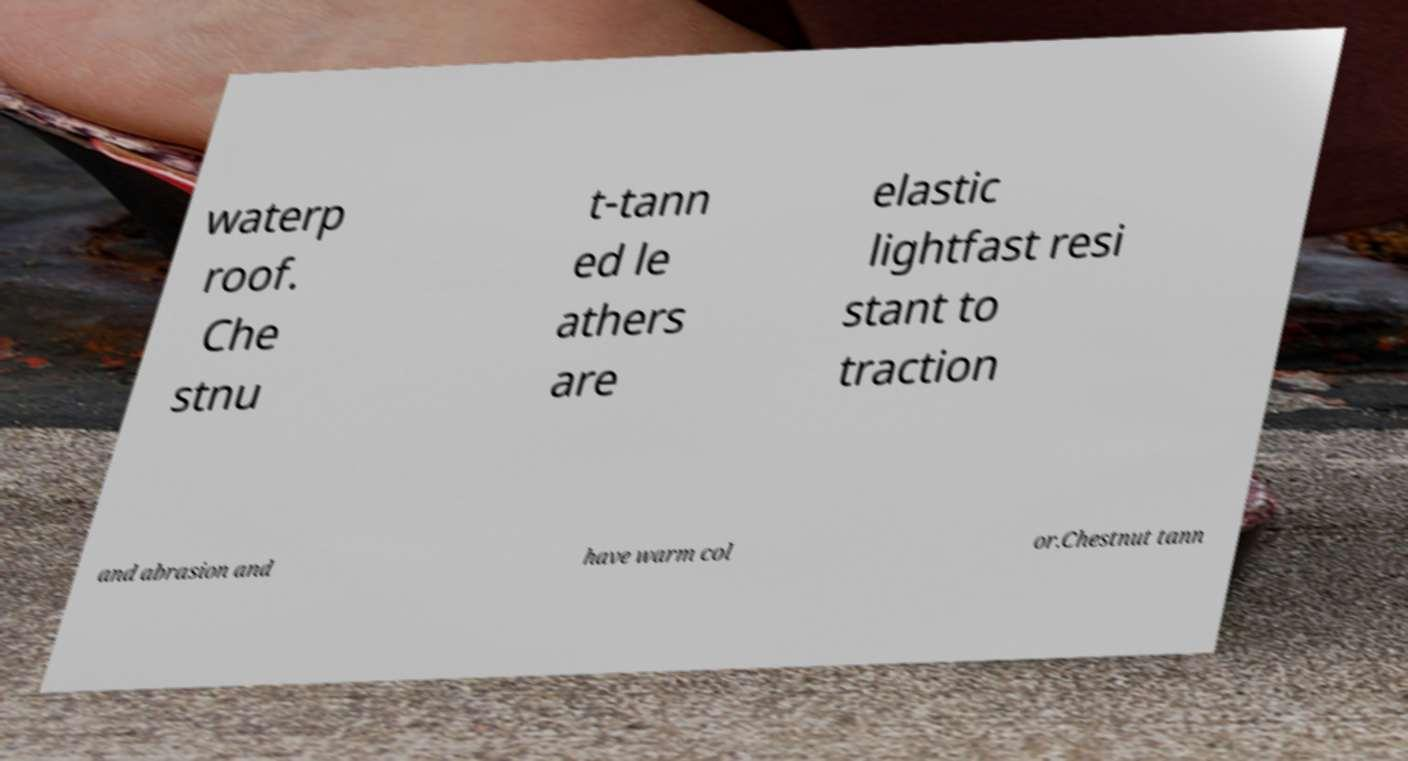Please identify and transcribe the text found in this image. waterp roof. Che stnu t-tann ed le athers are elastic lightfast resi stant to traction and abrasion and have warm col or.Chestnut tann 